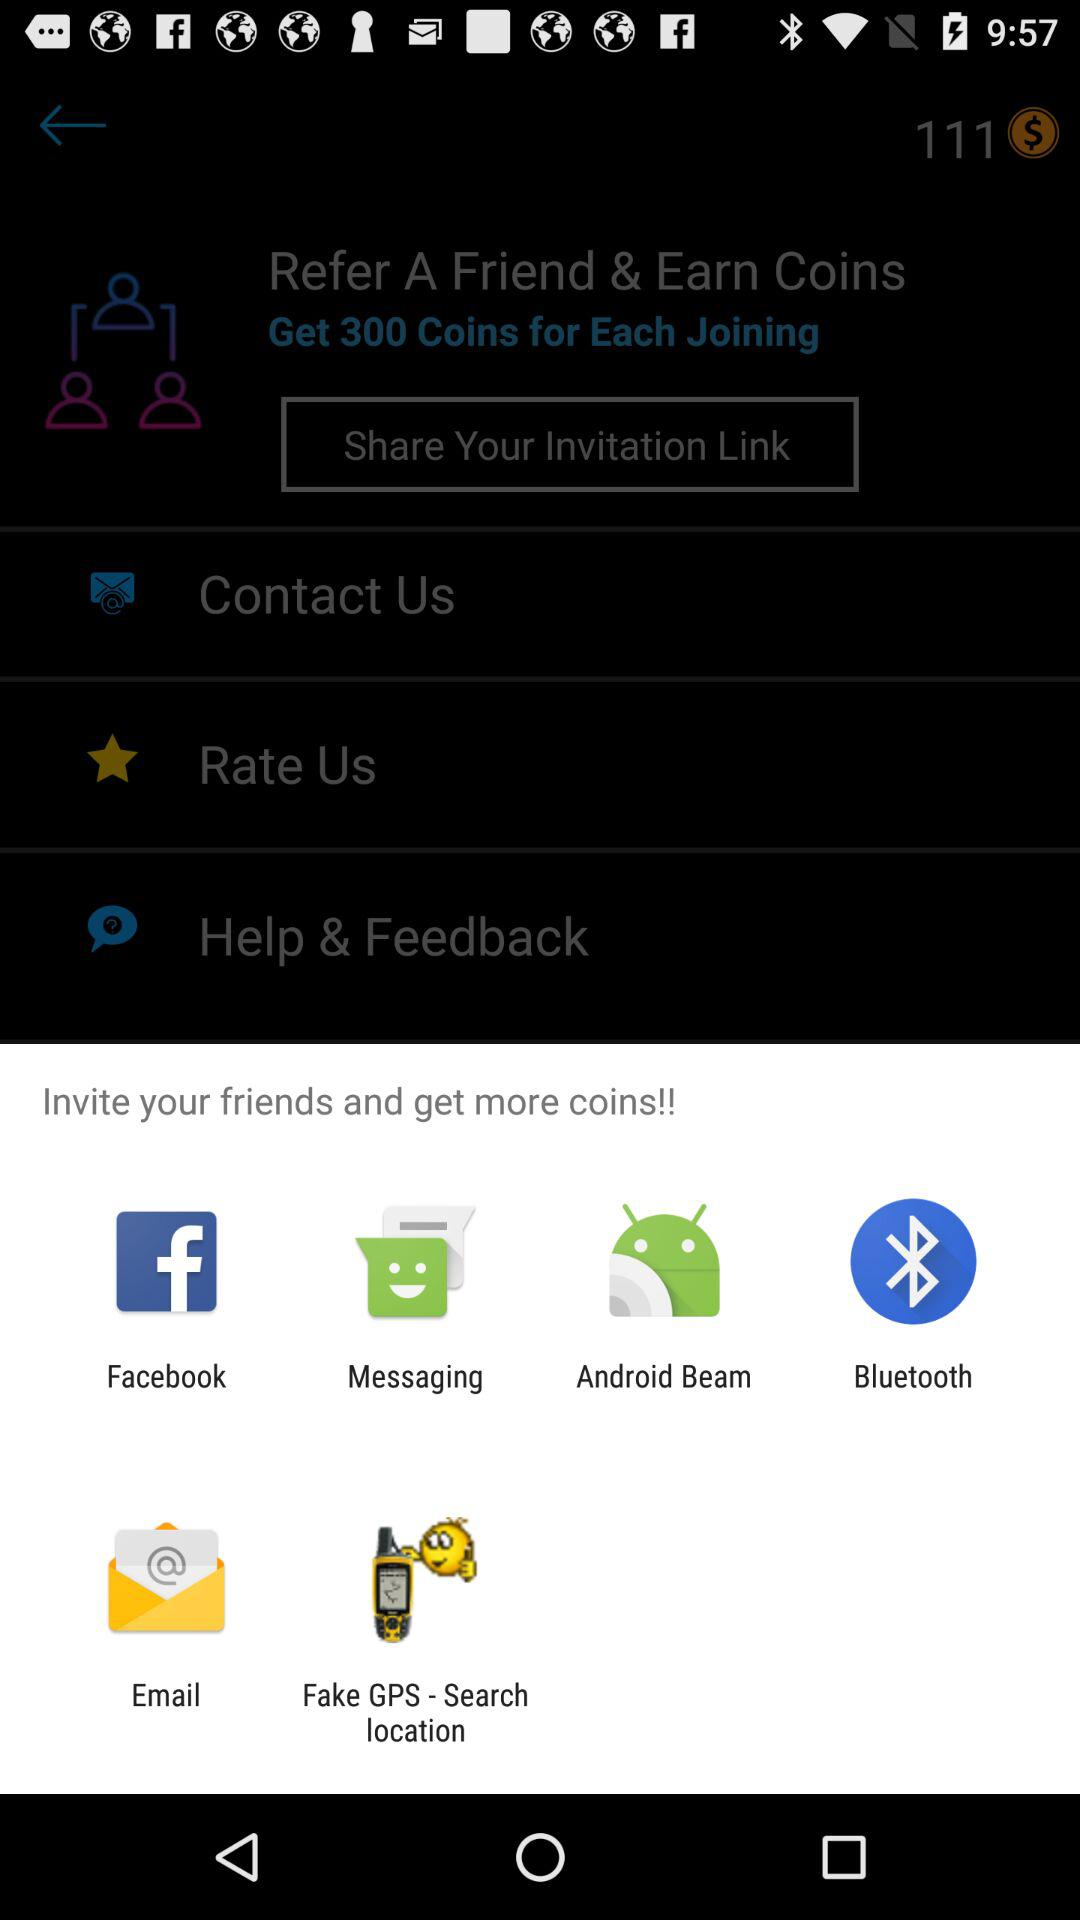What are the apps that can be used to invite friends and get more coins? The apps that can be used to invite friends and get more coins are "Facebook", "Messaging", "Android Beam", "Bluetooth", "Email" and "Fake GPS - Search location". 